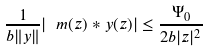<formula> <loc_0><loc_0><loc_500><loc_500>\frac { 1 } { b \| y \| } | \ m ( z ) * y ( z ) | \leq \frac { \Psi _ { 0 } } { 2 b | z | ^ { 2 } }</formula> 